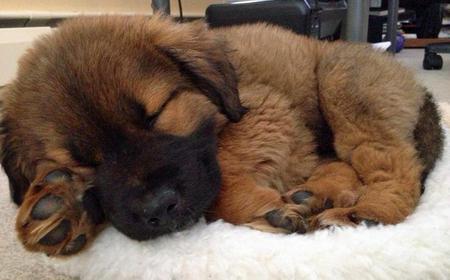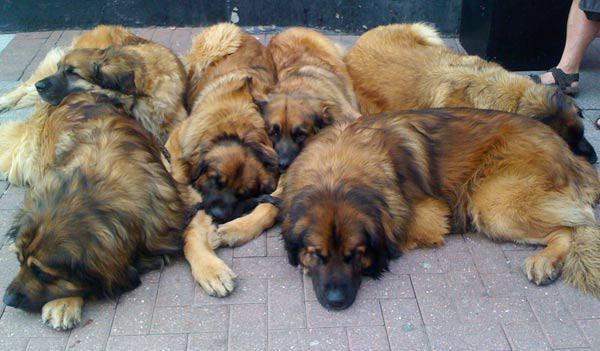The first image is the image on the left, the second image is the image on the right. Examine the images to the left and right. Is the description "In one of the images there are at least three large dogs laying on the ground next to each other." accurate? Answer yes or no. Yes. The first image is the image on the left, the second image is the image on the right. Examine the images to the left and right. Is the description "An image shows more than one dog lying in a sleeping pose." accurate? Answer yes or no. Yes. 